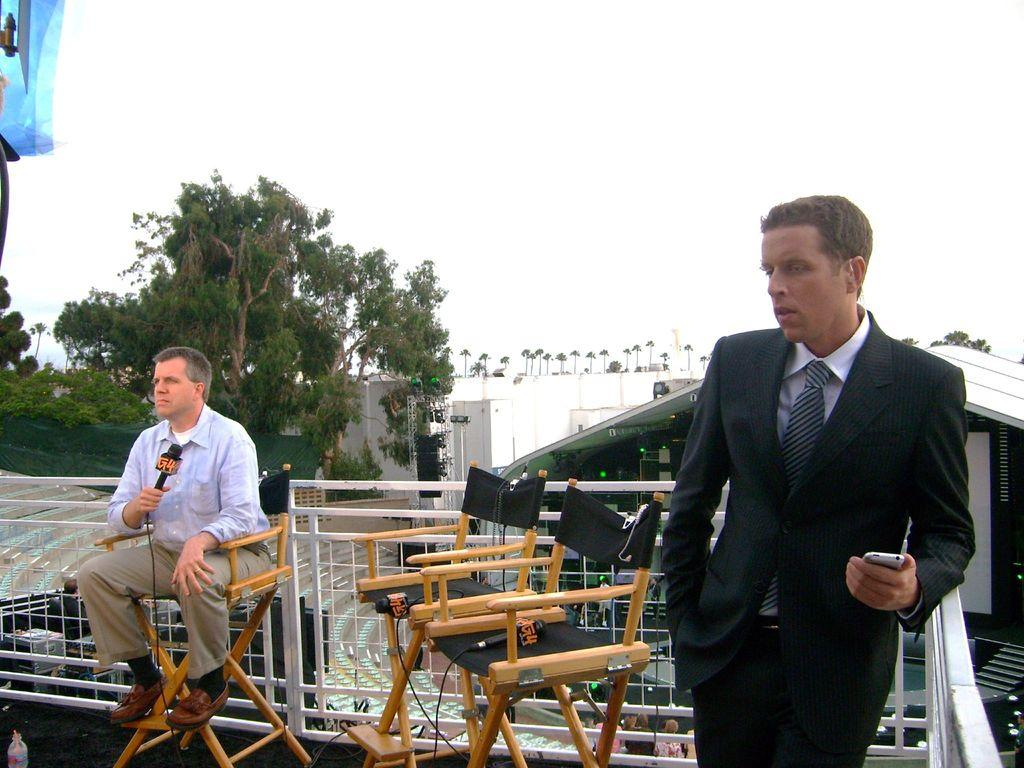How many people are in the image? There are two men in the image. What are the positions of the two men in the image? One man is standing, and the other man is sitting. What is the sitting man holding in his hand? The sitting man is holding a microphone in his hand. What can be seen in the background of the image? Trees are visible in the background of the image. What is the condition of the sky in the image? The sky is clear in the image. What type of insurance is being discussed by the men in the image? There is no indication in the image that the men are discussing insurance or any other topic. 